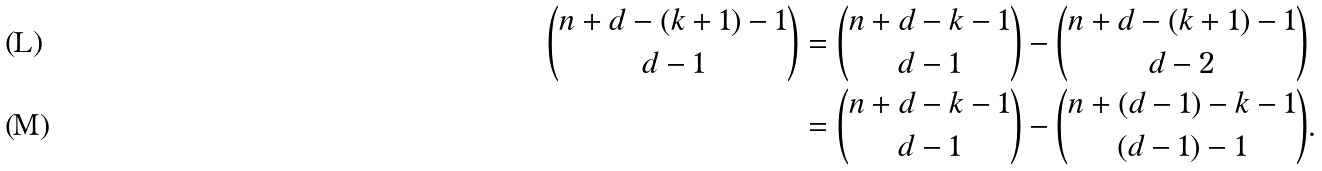Convert formula to latex. <formula><loc_0><loc_0><loc_500><loc_500>\binom { n + d - ( k + 1 ) - 1 } { d - 1 } & = \binom { n + d - k - 1 } { d - 1 } - \binom { n + d - ( k + 1 ) - 1 } { d - 2 } \\ & = \binom { n + d - k - 1 } { d - 1 } - \binom { n + ( d - 1 ) - k - 1 } { ( d - 1 ) - 1 } .</formula> 